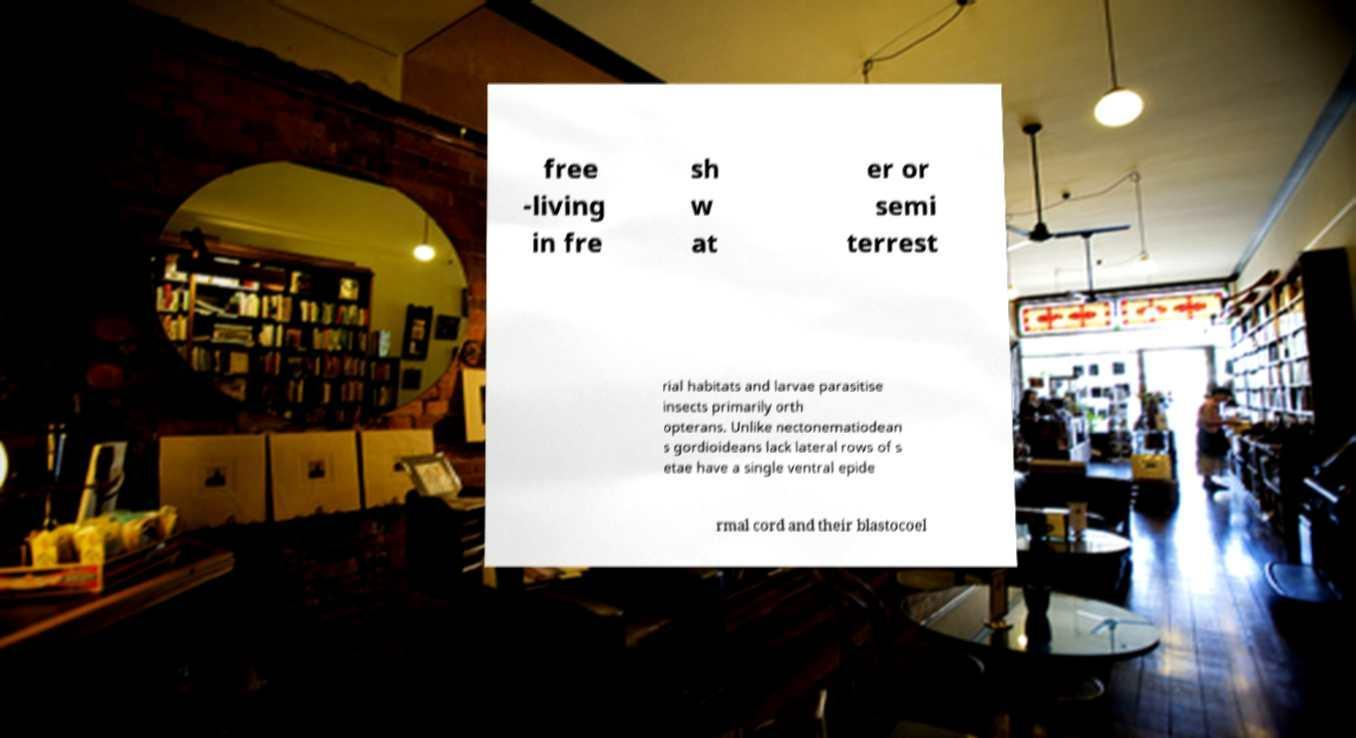I need the written content from this picture converted into text. Can you do that? free -living in fre sh w at er or semi terrest rial habitats and larvae parasitise insects primarily orth opterans. Unlike nectonematiodean s gordioideans lack lateral rows of s etae have a single ventral epide rmal cord and their blastocoel 